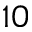<formula> <loc_0><loc_0><loc_500><loc_500>1 0</formula> 